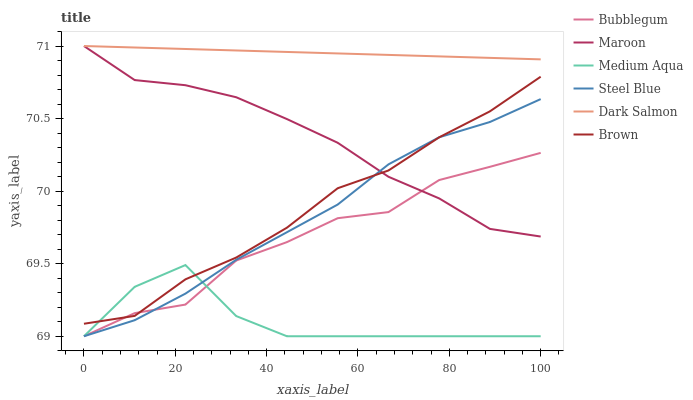Does Medium Aqua have the minimum area under the curve?
Answer yes or no. Yes. Does Dark Salmon have the maximum area under the curve?
Answer yes or no. Yes. Does Maroon have the minimum area under the curve?
Answer yes or no. No. Does Maroon have the maximum area under the curve?
Answer yes or no. No. Is Dark Salmon the smoothest?
Answer yes or no. Yes. Is Medium Aqua the roughest?
Answer yes or no. Yes. Is Maroon the smoothest?
Answer yes or no. No. Is Maroon the roughest?
Answer yes or no. No. Does Steel Blue have the lowest value?
Answer yes or no. Yes. Does Maroon have the lowest value?
Answer yes or no. No. Does Maroon have the highest value?
Answer yes or no. Yes. Does Steel Blue have the highest value?
Answer yes or no. No. Is Steel Blue less than Dark Salmon?
Answer yes or no. Yes. Is Dark Salmon greater than Medium Aqua?
Answer yes or no. Yes. Does Steel Blue intersect Brown?
Answer yes or no. Yes. Is Steel Blue less than Brown?
Answer yes or no. No. Is Steel Blue greater than Brown?
Answer yes or no. No. Does Steel Blue intersect Dark Salmon?
Answer yes or no. No. 